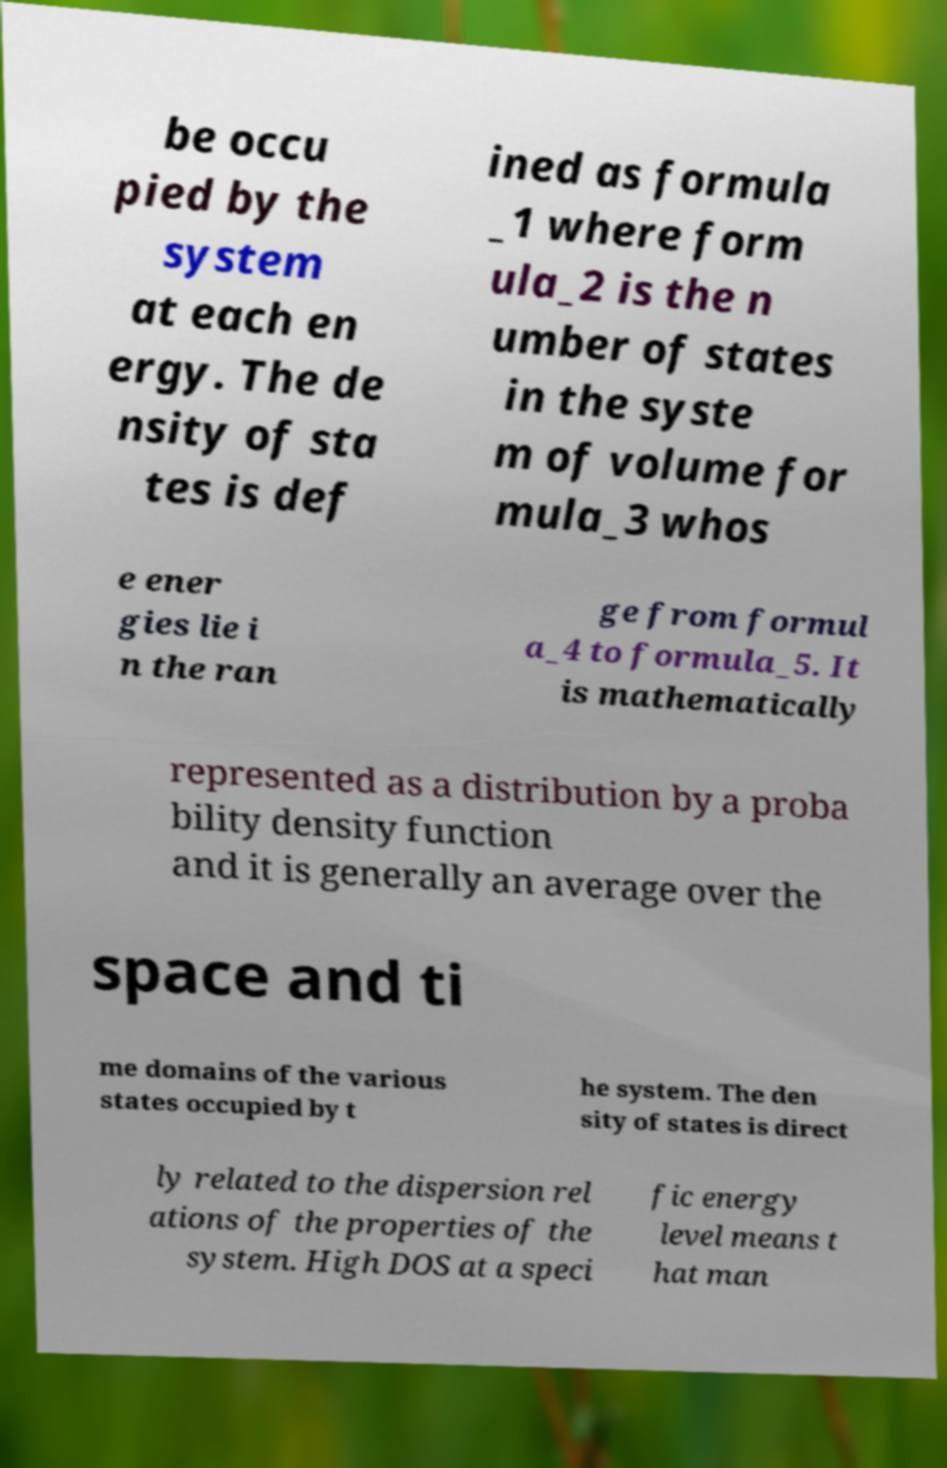Please identify and transcribe the text found in this image. be occu pied by the system at each en ergy. The de nsity of sta tes is def ined as formula _1 where form ula_2 is the n umber of states in the syste m of volume for mula_3 whos e ener gies lie i n the ran ge from formul a_4 to formula_5. It is mathematically represented as a distribution by a proba bility density function and it is generally an average over the space and ti me domains of the various states occupied by t he system. The den sity of states is direct ly related to the dispersion rel ations of the properties of the system. High DOS at a speci fic energy level means t hat man 